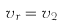<formula> <loc_0><loc_0><loc_500><loc_500>v _ { r } = v _ { 2 }</formula> 